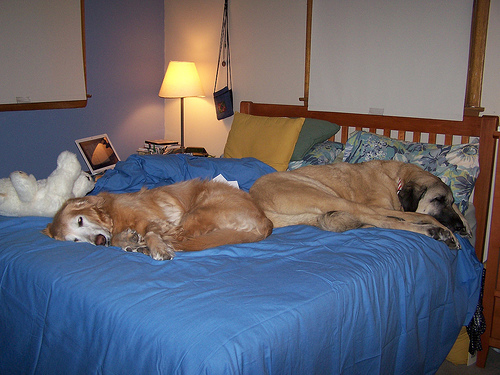<image>
Is there a dog on the bed? Yes. Looking at the image, I can see the dog is positioned on top of the bed, with the bed providing support. Is the dog behind the dog? No. The dog is not behind the dog. From this viewpoint, the dog appears to be positioned elsewhere in the scene. 